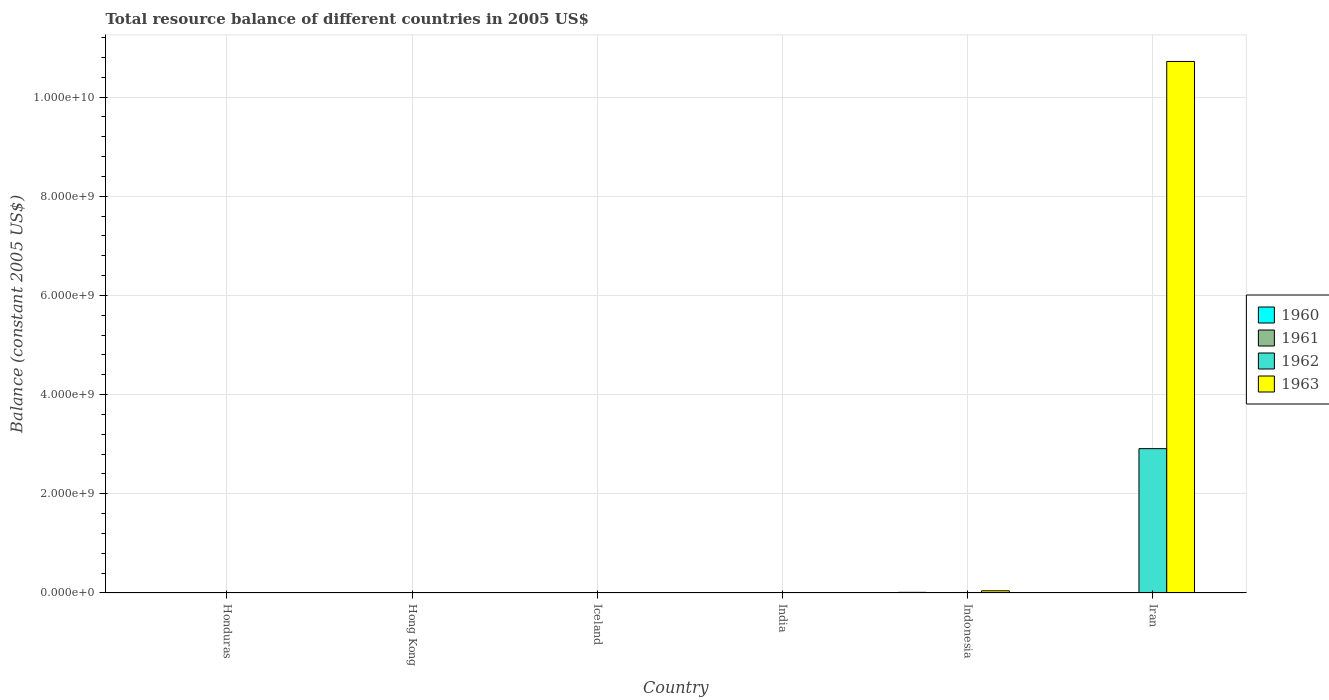How many different coloured bars are there?
Keep it short and to the point. 4. Are the number of bars per tick equal to the number of legend labels?
Your response must be concise. No. Are the number of bars on each tick of the X-axis equal?
Provide a short and direct response. No. How many bars are there on the 6th tick from the left?
Your response must be concise. 2. How many bars are there on the 3rd tick from the right?
Your answer should be very brief. 0. What is the label of the 2nd group of bars from the left?
Make the answer very short. Hong Kong. In how many cases, is the number of bars for a given country not equal to the number of legend labels?
Provide a short and direct response. 6. What is the total resource balance in 1962 in Indonesia?
Your answer should be compact. 9.90e+06. Across all countries, what is the maximum total resource balance in 1962?
Your answer should be very brief. 2.91e+09. Across all countries, what is the minimum total resource balance in 1963?
Your answer should be very brief. 0. What is the total total resource balance in 1962 in the graph?
Your answer should be very brief. 2.93e+09. What is the difference between the total resource balance in 1962 in Iceland and that in Indonesia?
Ensure brevity in your answer.  -5.68e+06. What is the difference between the total resource balance in 1961 in Iran and the total resource balance in 1963 in Honduras?
Keep it short and to the point. 0. What is the average total resource balance in 1963 per country?
Offer a very short reply. 1.79e+09. What is the difference between the total resource balance of/in 1961 and total resource balance of/in 1962 in Iceland?
Keep it short and to the point. -1.05e+06. Is the total resource balance in 1962 in Honduras less than that in Iceland?
Provide a short and direct response. Yes. What is the difference between the highest and the second highest total resource balance in 1962?
Provide a succinct answer. 5.68e+06. What is the difference between the highest and the lowest total resource balance in 1963?
Keep it short and to the point. 1.07e+1. Is it the case that in every country, the sum of the total resource balance in 1960 and total resource balance in 1963 is greater than the total resource balance in 1961?
Offer a terse response. No. Are all the bars in the graph horizontal?
Provide a short and direct response. No. How many countries are there in the graph?
Offer a terse response. 6. Are the values on the major ticks of Y-axis written in scientific E-notation?
Your answer should be very brief. Yes. Where does the legend appear in the graph?
Give a very brief answer. Center right. How are the legend labels stacked?
Offer a very short reply. Vertical. What is the title of the graph?
Your answer should be compact. Total resource balance of different countries in 2005 US$. What is the label or title of the X-axis?
Offer a terse response. Country. What is the label or title of the Y-axis?
Your answer should be compact. Balance (constant 2005 US$). What is the Balance (constant 2005 US$) in 1960 in Honduras?
Offer a terse response. 0. What is the Balance (constant 2005 US$) of 1961 in Honduras?
Ensure brevity in your answer.  2.80e+06. What is the Balance (constant 2005 US$) in 1962 in Honduras?
Your answer should be compact. 3.20e+06. What is the Balance (constant 2005 US$) of 1963 in Honduras?
Your response must be concise. 0. What is the Balance (constant 2005 US$) of 1960 in Hong Kong?
Your answer should be compact. 0. What is the Balance (constant 2005 US$) in 1961 in Hong Kong?
Make the answer very short. 0. What is the Balance (constant 2005 US$) of 1963 in Hong Kong?
Your answer should be compact. 0. What is the Balance (constant 2005 US$) in 1960 in Iceland?
Offer a very short reply. 0. What is the Balance (constant 2005 US$) in 1961 in Iceland?
Your answer should be very brief. 3.17e+06. What is the Balance (constant 2005 US$) in 1962 in Iceland?
Make the answer very short. 4.23e+06. What is the Balance (constant 2005 US$) of 1960 in India?
Your answer should be compact. 0. What is the Balance (constant 2005 US$) in 1962 in India?
Provide a short and direct response. 0. What is the Balance (constant 2005 US$) in 1960 in Indonesia?
Your answer should be compact. 1.30e+07. What is the Balance (constant 2005 US$) in 1962 in Indonesia?
Give a very brief answer. 9.90e+06. What is the Balance (constant 2005 US$) of 1963 in Indonesia?
Provide a succinct answer. 4.42e+07. What is the Balance (constant 2005 US$) in 1960 in Iran?
Your response must be concise. 0. What is the Balance (constant 2005 US$) of 1962 in Iran?
Your answer should be compact. 2.91e+09. What is the Balance (constant 2005 US$) in 1963 in Iran?
Your answer should be compact. 1.07e+1. Across all countries, what is the maximum Balance (constant 2005 US$) of 1960?
Give a very brief answer. 1.30e+07. Across all countries, what is the maximum Balance (constant 2005 US$) of 1961?
Provide a succinct answer. 3.17e+06. Across all countries, what is the maximum Balance (constant 2005 US$) of 1962?
Offer a terse response. 2.91e+09. Across all countries, what is the maximum Balance (constant 2005 US$) of 1963?
Give a very brief answer. 1.07e+1. What is the total Balance (constant 2005 US$) in 1960 in the graph?
Give a very brief answer. 1.30e+07. What is the total Balance (constant 2005 US$) of 1961 in the graph?
Provide a succinct answer. 5.97e+06. What is the total Balance (constant 2005 US$) of 1962 in the graph?
Your answer should be very brief. 2.93e+09. What is the total Balance (constant 2005 US$) in 1963 in the graph?
Your response must be concise. 1.08e+1. What is the difference between the Balance (constant 2005 US$) in 1961 in Honduras and that in Iceland?
Ensure brevity in your answer.  -3.74e+05. What is the difference between the Balance (constant 2005 US$) of 1962 in Honduras and that in Iceland?
Your answer should be compact. -1.03e+06. What is the difference between the Balance (constant 2005 US$) in 1962 in Honduras and that in Indonesia?
Provide a short and direct response. -6.70e+06. What is the difference between the Balance (constant 2005 US$) of 1962 in Honduras and that in Iran?
Provide a short and direct response. -2.91e+09. What is the difference between the Balance (constant 2005 US$) in 1962 in Iceland and that in Indonesia?
Provide a succinct answer. -5.68e+06. What is the difference between the Balance (constant 2005 US$) in 1962 in Iceland and that in Iran?
Give a very brief answer. -2.91e+09. What is the difference between the Balance (constant 2005 US$) in 1962 in Indonesia and that in Iran?
Keep it short and to the point. -2.90e+09. What is the difference between the Balance (constant 2005 US$) in 1963 in Indonesia and that in Iran?
Make the answer very short. -1.07e+1. What is the difference between the Balance (constant 2005 US$) of 1961 in Honduras and the Balance (constant 2005 US$) of 1962 in Iceland?
Your answer should be very brief. -1.43e+06. What is the difference between the Balance (constant 2005 US$) of 1961 in Honduras and the Balance (constant 2005 US$) of 1962 in Indonesia?
Offer a very short reply. -7.10e+06. What is the difference between the Balance (constant 2005 US$) in 1961 in Honduras and the Balance (constant 2005 US$) in 1963 in Indonesia?
Make the answer very short. -4.14e+07. What is the difference between the Balance (constant 2005 US$) of 1962 in Honduras and the Balance (constant 2005 US$) of 1963 in Indonesia?
Offer a terse response. -4.10e+07. What is the difference between the Balance (constant 2005 US$) of 1961 in Honduras and the Balance (constant 2005 US$) of 1962 in Iran?
Keep it short and to the point. -2.91e+09. What is the difference between the Balance (constant 2005 US$) of 1961 in Honduras and the Balance (constant 2005 US$) of 1963 in Iran?
Your answer should be very brief. -1.07e+1. What is the difference between the Balance (constant 2005 US$) of 1962 in Honduras and the Balance (constant 2005 US$) of 1963 in Iran?
Offer a terse response. -1.07e+1. What is the difference between the Balance (constant 2005 US$) of 1961 in Iceland and the Balance (constant 2005 US$) of 1962 in Indonesia?
Keep it short and to the point. -6.73e+06. What is the difference between the Balance (constant 2005 US$) in 1961 in Iceland and the Balance (constant 2005 US$) in 1963 in Indonesia?
Ensure brevity in your answer.  -4.10e+07. What is the difference between the Balance (constant 2005 US$) of 1962 in Iceland and the Balance (constant 2005 US$) of 1963 in Indonesia?
Your response must be concise. -4.00e+07. What is the difference between the Balance (constant 2005 US$) of 1961 in Iceland and the Balance (constant 2005 US$) of 1962 in Iran?
Your answer should be compact. -2.91e+09. What is the difference between the Balance (constant 2005 US$) in 1961 in Iceland and the Balance (constant 2005 US$) in 1963 in Iran?
Offer a very short reply. -1.07e+1. What is the difference between the Balance (constant 2005 US$) in 1962 in Iceland and the Balance (constant 2005 US$) in 1963 in Iran?
Provide a succinct answer. -1.07e+1. What is the difference between the Balance (constant 2005 US$) of 1960 in Indonesia and the Balance (constant 2005 US$) of 1962 in Iran?
Give a very brief answer. -2.90e+09. What is the difference between the Balance (constant 2005 US$) in 1960 in Indonesia and the Balance (constant 2005 US$) in 1963 in Iran?
Provide a short and direct response. -1.07e+1. What is the difference between the Balance (constant 2005 US$) in 1962 in Indonesia and the Balance (constant 2005 US$) in 1963 in Iran?
Give a very brief answer. -1.07e+1. What is the average Balance (constant 2005 US$) in 1960 per country?
Your response must be concise. 2.16e+06. What is the average Balance (constant 2005 US$) of 1961 per country?
Keep it short and to the point. 9.96e+05. What is the average Balance (constant 2005 US$) of 1962 per country?
Keep it short and to the point. 4.88e+08. What is the average Balance (constant 2005 US$) of 1963 per country?
Provide a short and direct response. 1.79e+09. What is the difference between the Balance (constant 2005 US$) in 1961 and Balance (constant 2005 US$) in 1962 in Honduras?
Your answer should be very brief. -4.00e+05. What is the difference between the Balance (constant 2005 US$) of 1961 and Balance (constant 2005 US$) of 1962 in Iceland?
Provide a short and direct response. -1.05e+06. What is the difference between the Balance (constant 2005 US$) in 1960 and Balance (constant 2005 US$) in 1962 in Indonesia?
Provide a short and direct response. 3.08e+06. What is the difference between the Balance (constant 2005 US$) in 1960 and Balance (constant 2005 US$) in 1963 in Indonesia?
Offer a very short reply. -3.12e+07. What is the difference between the Balance (constant 2005 US$) of 1962 and Balance (constant 2005 US$) of 1963 in Indonesia?
Provide a succinct answer. -3.43e+07. What is the difference between the Balance (constant 2005 US$) of 1962 and Balance (constant 2005 US$) of 1963 in Iran?
Provide a short and direct response. -7.81e+09. What is the ratio of the Balance (constant 2005 US$) in 1961 in Honduras to that in Iceland?
Provide a succinct answer. 0.88. What is the ratio of the Balance (constant 2005 US$) of 1962 in Honduras to that in Iceland?
Your answer should be very brief. 0.76. What is the ratio of the Balance (constant 2005 US$) of 1962 in Honduras to that in Indonesia?
Keep it short and to the point. 0.32. What is the ratio of the Balance (constant 2005 US$) in 1962 in Honduras to that in Iran?
Give a very brief answer. 0. What is the ratio of the Balance (constant 2005 US$) of 1962 in Iceland to that in Indonesia?
Your answer should be very brief. 0.43. What is the ratio of the Balance (constant 2005 US$) of 1962 in Iceland to that in Iran?
Ensure brevity in your answer.  0. What is the ratio of the Balance (constant 2005 US$) in 1962 in Indonesia to that in Iran?
Keep it short and to the point. 0. What is the ratio of the Balance (constant 2005 US$) in 1963 in Indonesia to that in Iran?
Your answer should be very brief. 0. What is the difference between the highest and the second highest Balance (constant 2005 US$) of 1962?
Keep it short and to the point. 2.90e+09. What is the difference between the highest and the lowest Balance (constant 2005 US$) in 1960?
Offer a very short reply. 1.30e+07. What is the difference between the highest and the lowest Balance (constant 2005 US$) in 1961?
Provide a short and direct response. 3.17e+06. What is the difference between the highest and the lowest Balance (constant 2005 US$) of 1962?
Ensure brevity in your answer.  2.91e+09. What is the difference between the highest and the lowest Balance (constant 2005 US$) in 1963?
Offer a terse response. 1.07e+1. 